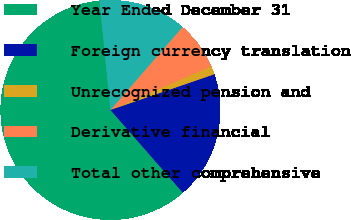Convert chart to OTSL. <chart><loc_0><loc_0><loc_500><loc_500><pie_chart><fcel>Year Ended December 31<fcel>Foreign currency translation<fcel>Unrecognized pension and<fcel>Derivative financial<fcel>Total other comprehensive<nl><fcel>59.86%<fcel>18.83%<fcel>1.24%<fcel>7.1%<fcel>12.97%<nl></chart> 